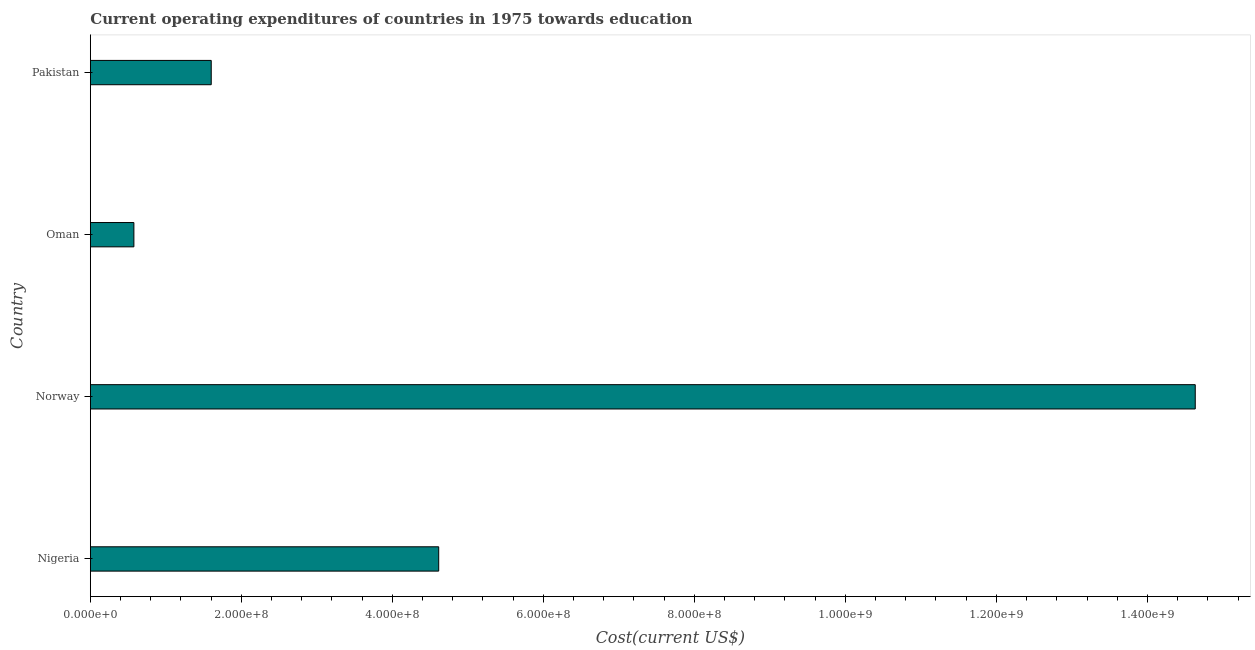Does the graph contain any zero values?
Ensure brevity in your answer.  No. What is the title of the graph?
Offer a terse response. Current operating expenditures of countries in 1975 towards education. What is the label or title of the X-axis?
Provide a succinct answer. Cost(current US$). What is the education expenditure in Pakistan?
Your answer should be very brief. 1.60e+08. Across all countries, what is the maximum education expenditure?
Provide a succinct answer. 1.46e+09. Across all countries, what is the minimum education expenditure?
Your answer should be compact. 5.76e+07. In which country was the education expenditure maximum?
Offer a very short reply. Norway. In which country was the education expenditure minimum?
Provide a succinct answer. Oman. What is the sum of the education expenditure?
Offer a terse response. 2.14e+09. What is the difference between the education expenditure in Nigeria and Norway?
Your answer should be compact. -1.00e+09. What is the average education expenditure per country?
Your answer should be very brief. 5.36e+08. What is the median education expenditure?
Offer a terse response. 3.11e+08. In how many countries, is the education expenditure greater than 320000000 US$?
Your answer should be compact. 2. What is the ratio of the education expenditure in Nigeria to that in Norway?
Make the answer very short. 0.32. What is the difference between the highest and the second highest education expenditure?
Offer a very short reply. 1.00e+09. What is the difference between the highest and the lowest education expenditure?
Your response must be concise. 1.41e+09. How many bars are there?
Ensure brevity in your answer.  4. Are all the bars in the graph horizontal?
Give a very brief answer. Yes. How many countries are there in the graph?
Give a very brief answer. 4. What is the Cost(current US$) of Nigeria?
Offer a very short reply. 4.61e+08. What is the Cost(current US$) in Norway?
Your answer should be compact. 1.46e+09. What is the Cost(current US$) in Oman?
Offer a terse response. 5.76e+07. What is the Cost(current US$) of Pakistan?
Provide a succinct answer. 1.60e+08. What is the difference between the Cost(current US$) in Nigeria and Norway?
Offer a very short reply. -1.00e+09. What is the difference between the Cost(current US$) in Nigeria and Oman?
Your response must be concise. 4.04e+08. What is the difference between the Cost(current US$) in Nigeria and Pakistan?
Offer a very short reply. 3.01e+08. What is the difference between the Cost(current US$) in Norway and Oman?
Offer a terse response. 1.41e+09. What is the difference between the Cost(current US$) in Norway and Pakistan?
Offer a terse response. 1.30e+09. What is the difference between the Cost(current US$) in Oman and Pakistan?
Make the answer very short. -1.02e+08. What is the ratio of the Cost(current US$) in Nigeria to that in Norway?
Your response must be concise. 0.32. What is the ratio of the Cost(current US$) in Nigeria to that in Oman?
Your answer should be very brief. 8. What is the ratio of the Cost(current US$) in Nigeria to that in Pakistan?
Provide a short and direct response. 2.88. What is the ratio of the Cost(current US$) in Norway to that in Oman?
Your answer should be very brief. 25.39. What is the ratio of the Cost(current US$) in Norway to that in Pakistan?
Offer a very short reply. 9.14. What is the ratio of the Cost(current US$) in Oman to that in Pakistan?
Give a very brief answer. 0.36. 